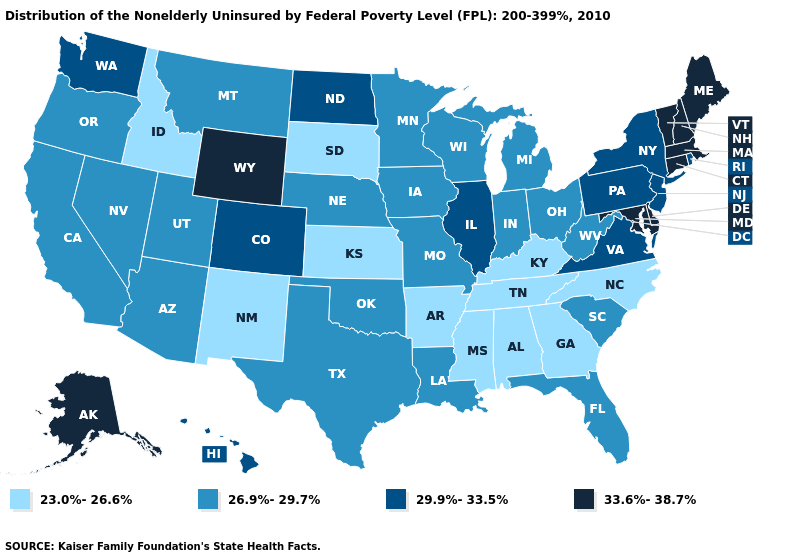What is the value of North Dakota?
Answer briefly. 29.9%-33.5%. What is the value of Kentucky?
Concise answer only. 23.0%-26.6%. What is the value of Ohio?
Give a very brief answer. 26.9%-29.7%. Is the legend a continuous bar?
Keep it brief. No. Name the states that have a value in the range 23.0%-26.6%?
Write a very short answer. Alabama, Arkansas, Georgia, Idaho, Kansas, Kentucky, Mississippi, New Mexico, North Carolina, South Dakota, Tennessee. What is the value of Illinois?
Short answer required. 29.9%-33.5%. Which states have the highest value in the USA?
Answer briefly. Alaska, Connecticut, Delaware, Maine, Maryland, Massachusetts, New Hampshire, Vermont, Wyoming. Name the states that have a value in the range 33.6%-38.7%?
Give a very brief answer. Alaska, Connecticut, Delaware, Maine, Maryland, Massachusetts, New Hampshire, Vermont, Wyoming. How many symbols are there in the legend?
Short answer required. 4. Does the first symbol in the legend represent the smallest category?
Write a very short answer. Yes. Name the states that have a value in the range 23.0%-26.6%?
Write a very short answer. Alabama, Arkansas, Georgia, Idaho, Kansas, Kentucky, Mississippi, New Mexico, North Carolina, South Dakota, Tennessee. Does Maine have a higher value than Delaware?
Quick response, please. No. What is the value of Wyoming?
Be succinct. 33.6%-38.7%. Name the states that have a value in the range 26.9%-29.7%?
Answer briefly. Arizona, California, Florida, Indiana, Iowa, Louisiana, Michigan, Minnesota, Missouri, Montana, Nebraska, Nevada, Ohio, Oklahoma, Oregon, South Carolina, Texas, Utah, West Virginia, Wisconsin. Does Maryland have the lowest value in the USA?
Be succinct. No. 